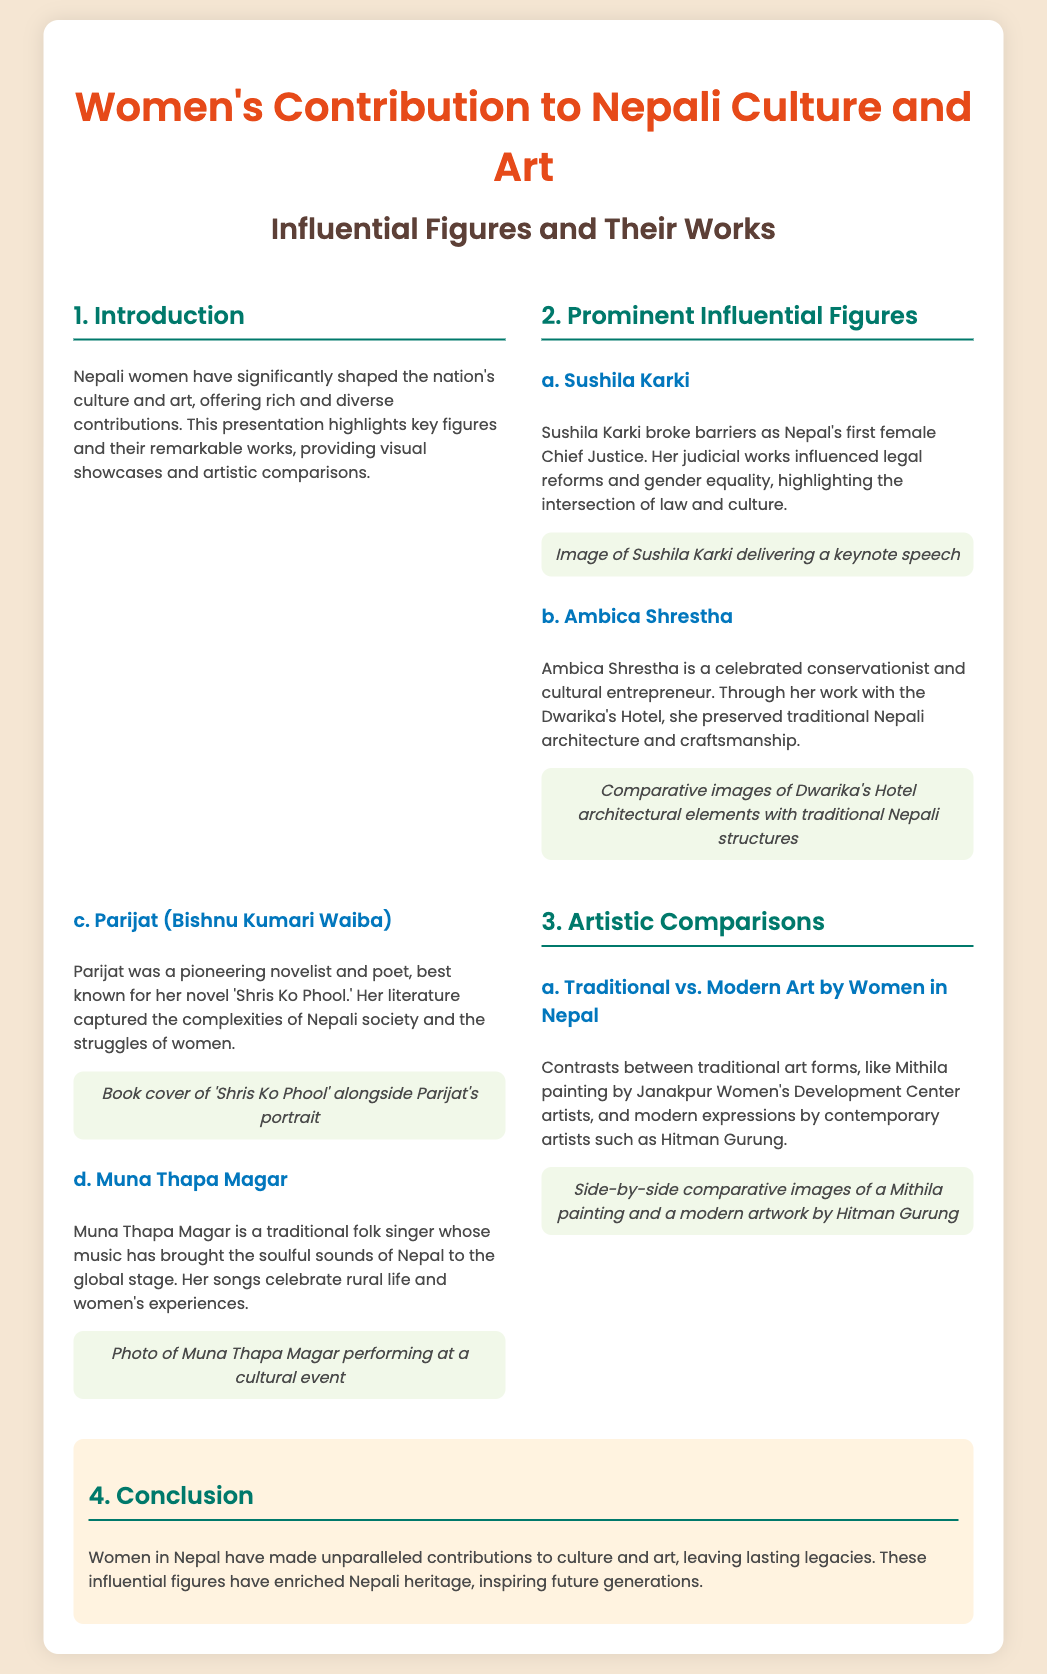what is the title of the presentation? The title of the presentation is the main heading as indicated in the document.
Answer: Women's Contribution to Nepali Culture and Art who is Nepal's first female Chief Justice? This information is found in the section about prominent influential figures.
Answer: Sushila Karki what is Parijat's famous novel? The novel is mentioned as a key work that defines Parijat's literary contributions in the document.
Answer: Shris Ko Phool who is a well-known conservationist and cultural entrepreneur? This figure is highlighted in the document for her work with traditional Nepali architecture.
Answer: Ambica Shrestha what type of music does Muna Thapa Magar perform? The type of her musical work is related to traditional genres celebrated in her performances.
Answer: Folk how does the document contrast traditional and modern art? The presentation discusses the difference between traditional art forms and contemporary expressions.
Answer: By comparing Mithila painting and modern artworks what is a key theme captured in Parijat's literature? The document identifies significant societal issues represented in her writing.
Answer: Struggles of women what event does the visual showcase of Muna Thapa Magar depict? This showcase features her performance, which emphasizes her contribution to Nepali culture.
Answer: A cultural event how are the comparative images presented in the document? The document mentions a visual comparison to illustrate contrasts within artistic expressions.
Answer: Side-by-side 